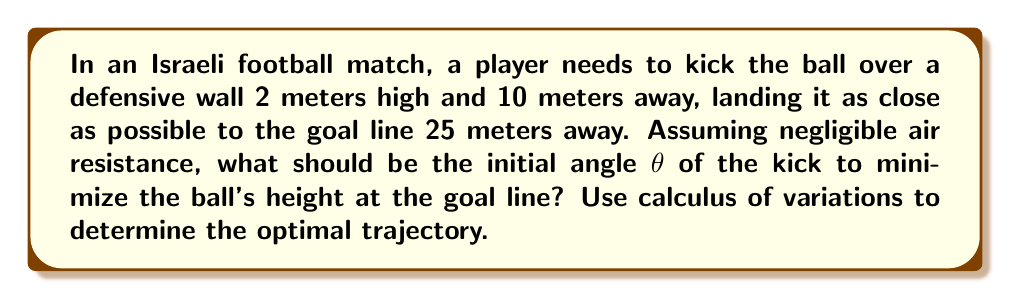What is the answer to this math problem? To solve this problem, we'll use the calculus of variations to find the optimal trajectory. Let's approach this step-by-step:

1) The trajectory of the ball can be described by a parabola:

   $$ y = ax - bx^2 $$

   where $y$ is the height and $x$ is the horizontal distance.

2) We need to satisfy these conditions:
   - At $x = 0$, $y = 0$ (starting point)
   - At $x = 10$, $y = 2$ (over the wall)
   - At $x = 25$, $y$ should be minimized (goal line)

3) From the first two conditions:

   $$ 2 = 10a - 100b $$

4) We want to minimize $y$ at $x = 25$. The height at this point is:

   $$ y_{25} = 25a - 625b $$

5) Using the constraint from step 3, we can express $a$ in terms of $b$:

   $$ a = 0.2 + 10b $$

6) Substituting this into the expression for $y_{25}$:

   $$ y_{25} = 25(0.2 + 10b) - 625b = 5 - 375b $$

7) To minimize $y_{25}$, we need to maximize $b$. However, $b$ is constrained by the need for the ball to clear the wall.

8) The maximum value of $b$ that satisfies the wall constraint is:

   $$ b = \frac{0.2}{100} = 0.002 $$

9) With this value of $b$, we can find $a$:

   $$ a = 0.2 + 10(0.002) = 0.22 $$

10) The initial angle θ can be found from the slope of the trajectory at $x = 0$:

    $$ \tan θ = \frac{dy}{dx}\bigg|_{x=0} = a = 0.22 $$

11) Therefore:

    $$ θ = \arctan(0.22) \approx 12.4° $$
Answer: $θ \approx 12.4°$ 